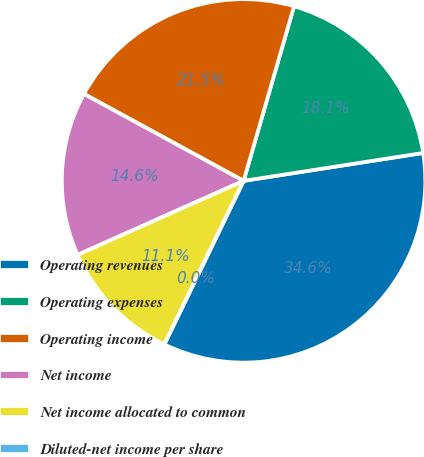<chart> <loc_0><loc_0><loc_500><loc_500><pie_chart><fcel>Operating revenues<fcel>Operating expenses<fcel>Operating income<fcel>Net income<fcel>Net income allocated to common<fcel>Diluted-net income per share<nl><fcel>34.64%<fcel>18.07%<fcel>21.54%<fcel>14.61%<fcel>11.14%<fcel>0.0%<nl></chart> 